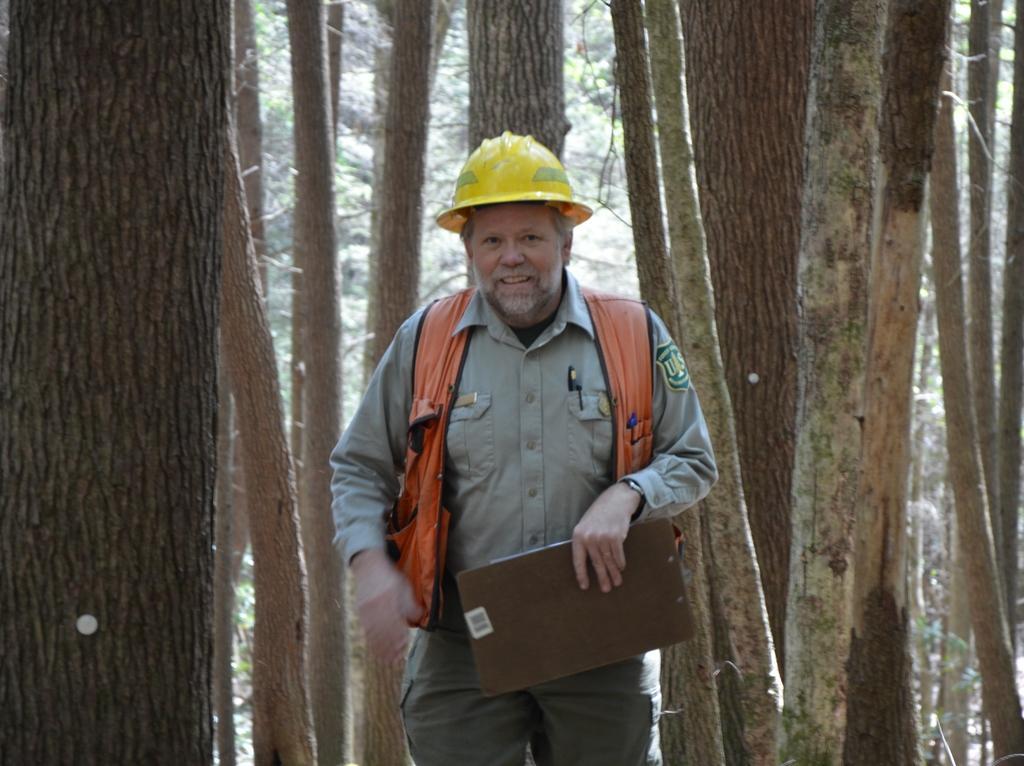Can you describe this image briefly? In this image we can see a person wearing dress with helmet on his head is holding a pad in his hand. In the background we can see group of trees. 